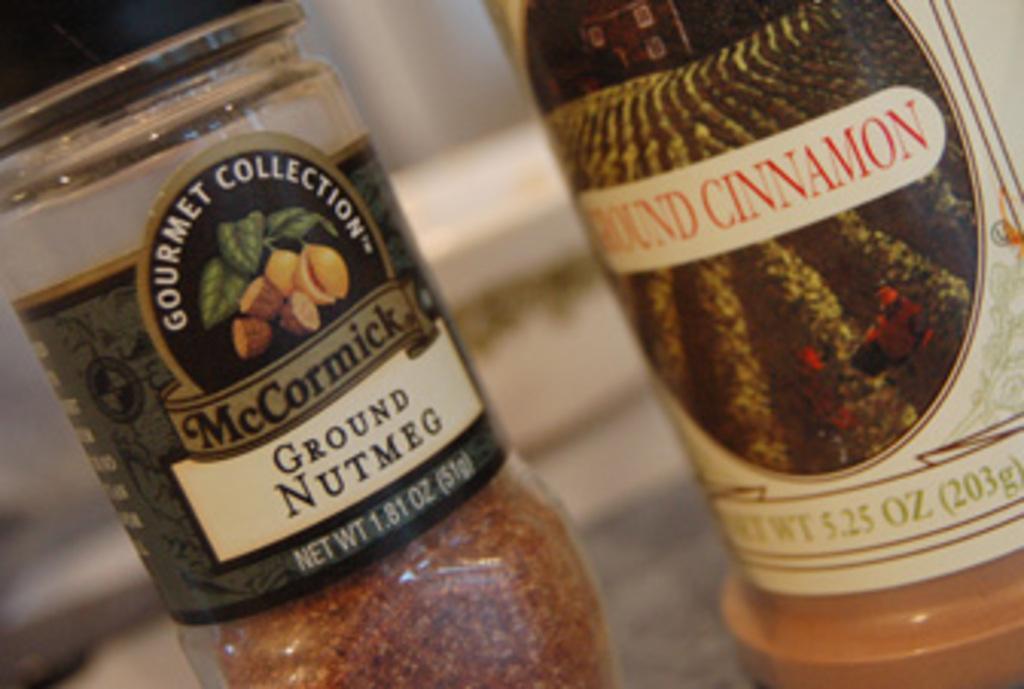How would you summarize this image in a sentence or two? In this picture we can see two bottles on which the labels are with white, red, black and golden color. 